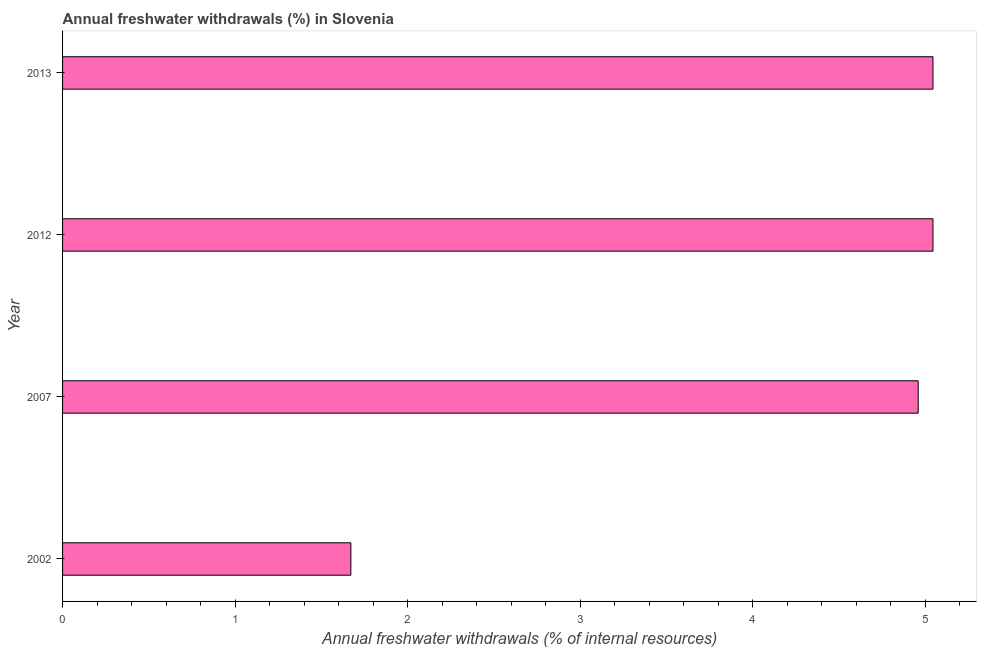Does the graph contain grids?
Offer a terse response. No. What is the title of the graph?
Provide a succinct answer. Annual freshwater withdrawals (%) in Slovenia. What is the label or title of the X-axis?
Give a very brief answer. Annual freshwater withdrawals (% of internal resources). What is the label or title of the Y-axis?
Your response must be concise. Year. What is the annual freshwater withdrawals in 2002?
Keep it short and to the point. 1.67. Across all years, what is the maximum annual freshwater withdrawals?
Give a very brief answer. 5.05. Across all years, what is the minimum annual freshwater withdrawals?
Give a very brief answer. 1.67. In which year was the annual freshwater withdrawals maximum?
Offer a very short reply. 2012. In which year was the annual freshwater withdrawals minimum?
Offer a very short reply. 2002. What is the sum of the annual freshwater withdrawals?
Provide a short and direct response. 16.72. What is the difference between the annual freshwater withdrawals in 2007 and 2013?
Provide a short and direct response. -0.09. What is the average annual freshwater withdrawals per year?
Keep it short and to the point. 4.18. What is the median annual freshwater withdrawals?
Make the answer very short. 5. In how many years, is the annual freshwater withdrawals greater than 2.6 %?
Your answer should be very brief. 3. What is the difference between the highest and the second highest annual freshwater withdrawals?
Give a very brief answer. 0. What is the difference between the highest and the lowest annual freshwater withdrawals?
Offer a terse response. 3.37. In how many years, is the annual freshwater withdrawals greater than the average annual freshwater withdrawals taken over all years?
Give a very brief answer. 3. How many bars are there?
Keep it short and to the point. 4. Are the values on the major ticks of X-axis written in scientific E-notation?
Offer a very short reply. No. What is the Annual freshwater withdrawals (% of internal resources) in 2002?
Ensure brevity in your answer.  1.67. What is the Annual freshwater withdrawals (% of internal resources) in 2007?
Provide a succinct answer. 4.96. What is the Annual freshwater withdrawals (% of internal resources) of 2012?
Offer a terse response. 5.05. What is the Annual freshwater withdrawals (% of internal resources) in 2013?
Offer a terse response. 5.05. What is the difference between the Annual freshwater withdrawals (% of internal resources) in 2002 and 2007?
Your answer should be very brief. -3.29. What is the difference between the Annual freshwater withdrawals (% of internal resources) in 2002 and 2012?
Your response must be concise. -3.37. What is the difference between the Annual freshwater withdrawals (% of internal resources) in 2002 and 2013?
Keep it short and to the point. -3.37. What is the difference between the Annual freshwater withdrawals (% of internal resources) in 2007 and 2012?
Ensure brevity in your answer.  -0.09. What is the difference between the Annual freshwater withdrawals (% of internal resources) in 2007 and 2013?
Ensure brevity in your answer.  -0.09. What is the difference between the Annual freshwater withdrawals (% of internal resources) in 2012 and 2013?
Offer a terse response. 0. What is the ratio of the Annual freshwater withdrawals (% of internal resources) in 2002 to that in 2007?
Offer a very short reply. 0.34. What is the ratio of the Annual freshwater withdrawals (% of internal resources) in 2002 to that in 2012?
Keep it short and to the point. 0.33. What is the ratio of the Annual freshwater withdrawals (% of internal resources) in 2002 to that in 2013?
Keep it short and to the point. 0.33. What is the ratio of the Annual freshwater withdrawals (% of internal resources) in 2007 to that in 2012?
Make the answer very short. 0.98. What is the ratio of the Annual freshwater withdrawals (% of internal resources) in 2007 to that in 2013?
Provide a short and direct response. 0.98. What is the ratio of the Annual freshwater withdrawals (% of internal resources) in 2012 to that in 2013?
Provide a short and direct response. 1. 